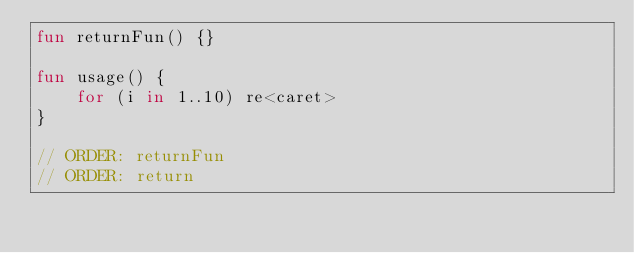Convert code to text. <code><loc_0><loc_0><loc_500><loc_500><_Kotlin_>fun returnFun() {}

fun usage() {
    for (i in 1..10) re<caret>
}

// ORDER: returnFun
// ORDER: return
</code> 